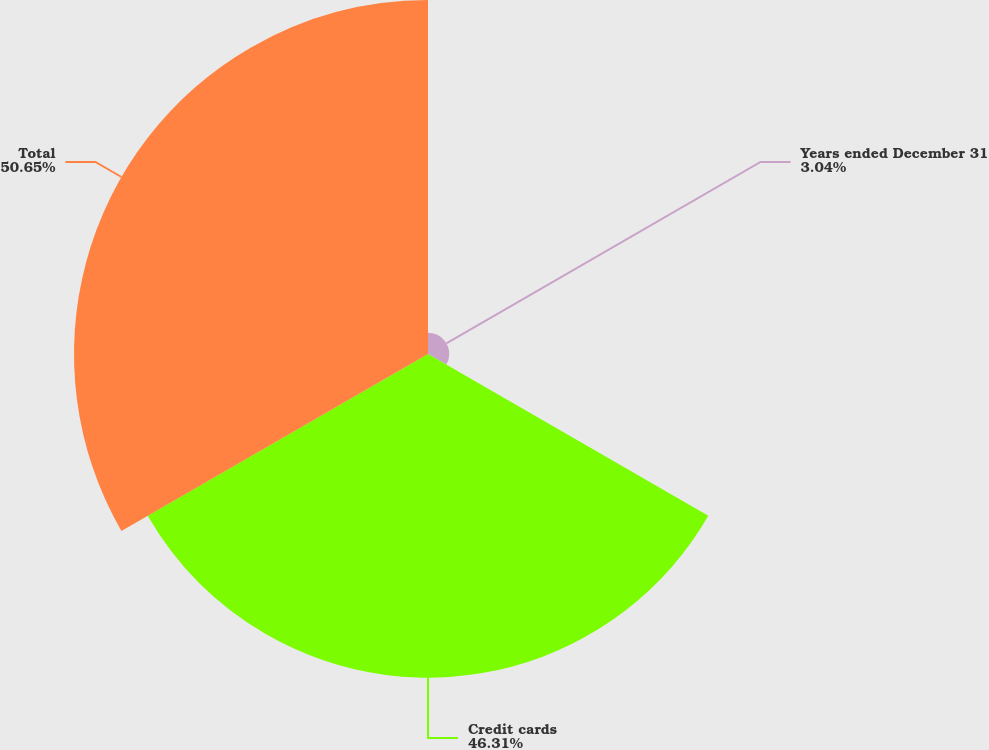Convert chart. <chart><loc_0><loc_0><loc_500><loc_500><pie_chart><fcel>Years ended December 31<fcel>Credit cards<fcel>Total<nl><fcel>3.04%<fcel>46.31%<fcel>50.65%<nl></chart> 